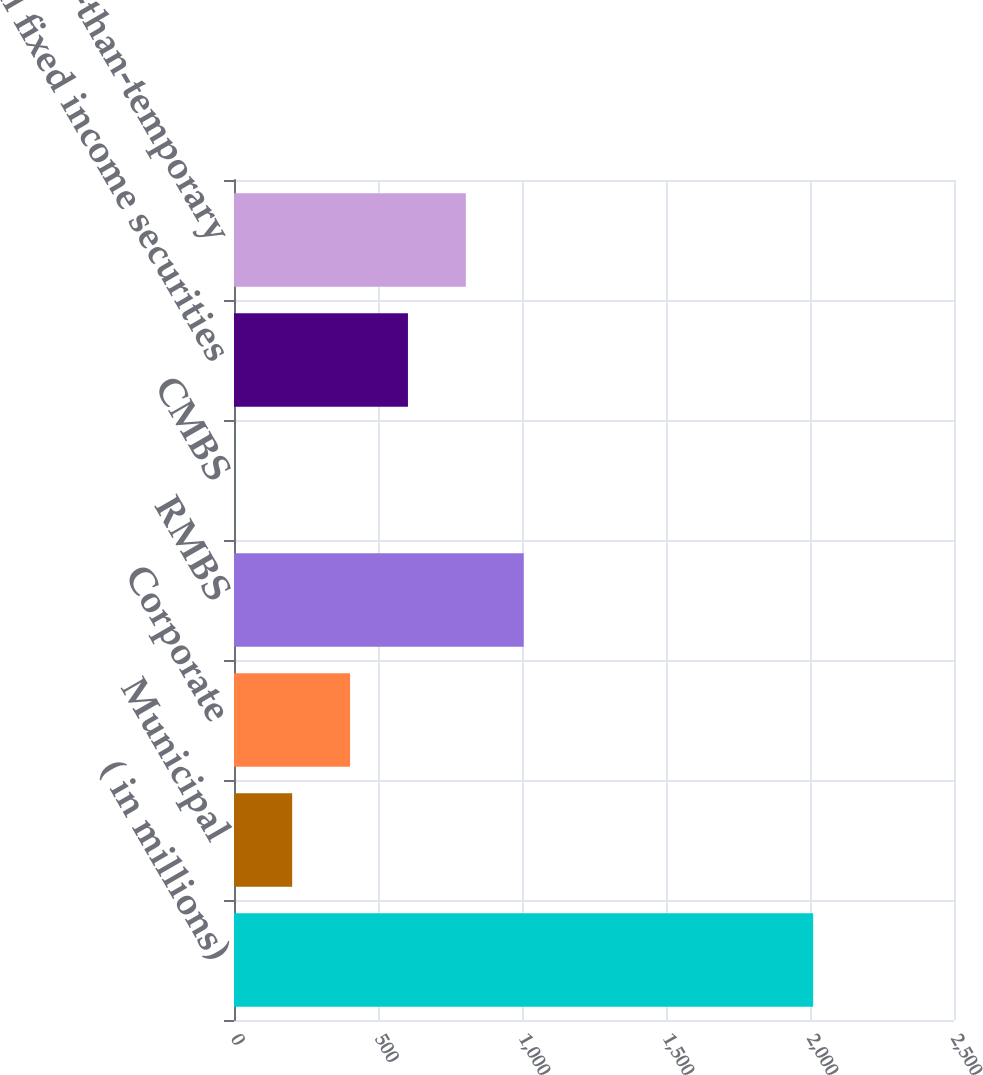Convert chart. <chart><loc_0><loc_0><loc_500><loc_500><bar_chart><fcel>( in millions)<fcel>Municipal<fcel>Corporate<fcel>RMBS<fcel>CMBS<fcel>Total fixed income securities<fcel>Other-than-temporary<nl><fcel>2011<fcel>202<fcel>403<fcel>1006<fcel>1<fcel>604<fcel>805<nl></chart> 